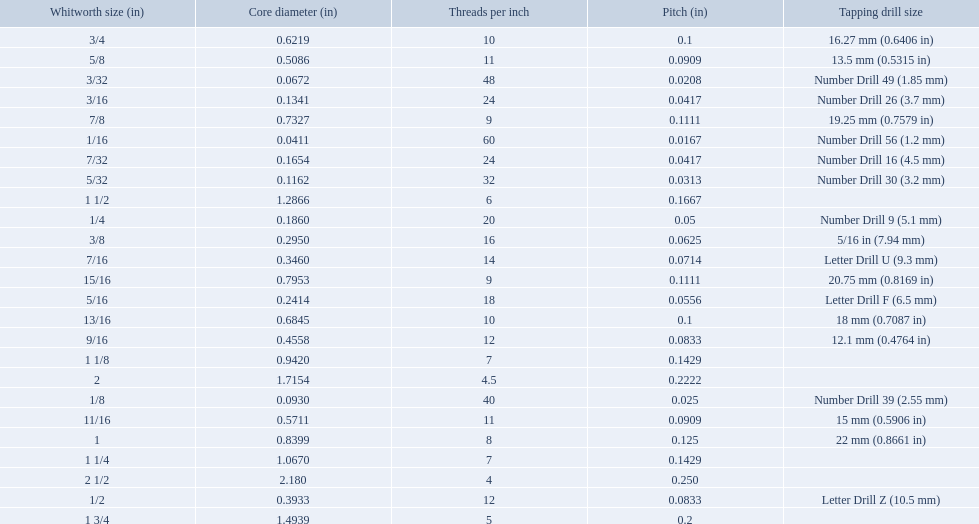What are the sizes of threads per inch? 60, 48, 40, 32, 24, 24, 20, 18, 16, 14, 12, 12, 11, 11, 10, 10, 9, 9, 8, 7, 7, 6, 5, 4.5, 4. Which whitworth size has only 5 threads per inch? 1 3/4. 